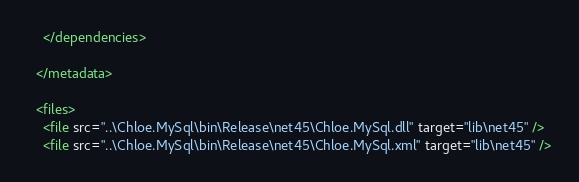<code> <loc_0><loc_0><loc_500><loc_500><_XML_>    </dependencies>
    
  </metadata>

  <files>
	<file src="..\Chloe.MySql\bin\Release\net45\Chloe.MySql.dll" target="lib\net45" />
    <file src="..\Chloe.MySql\bin\Release\net45\Chloe.MySql.xml" target="lib\net45" /></code> 